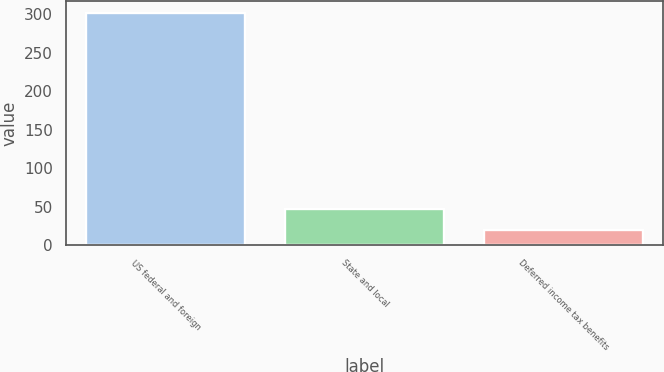Convert chart to OTSL. <chart><loc_0><loc_0><loc_500><loc_500><bar_chart><fcel>US federal and foreign<fcel>State and local<fcel>Deferred income tax benefits<nl><fcel>301.9<fcel>47.29<fcel>19<nl></chart> 